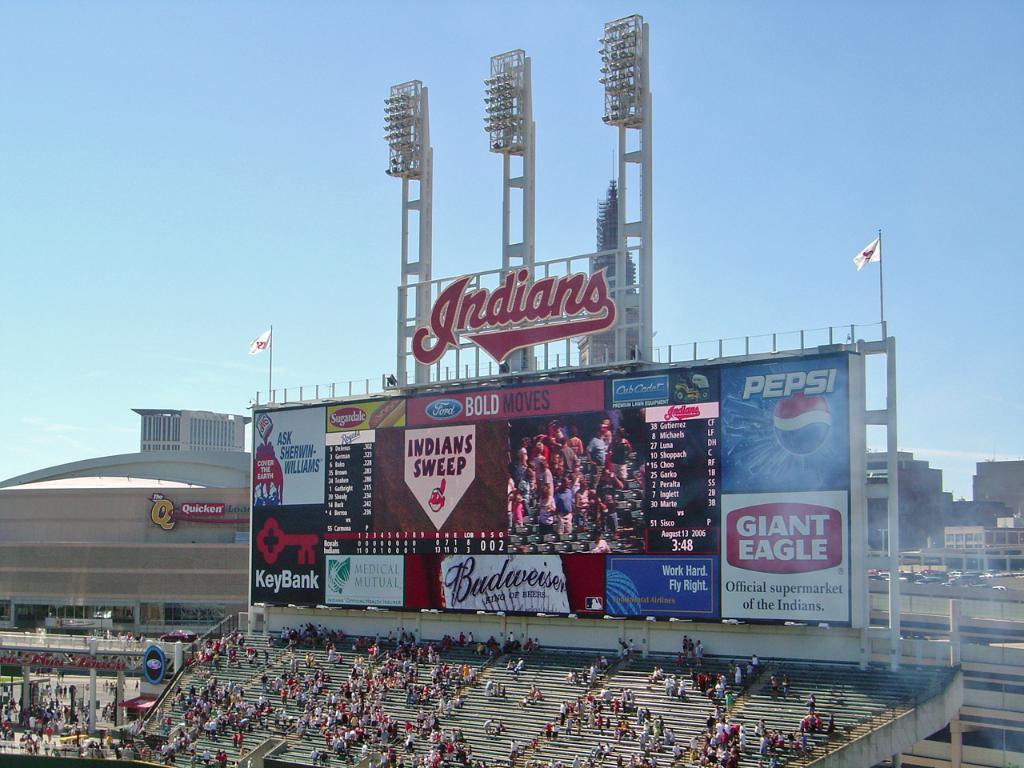<image>
Offer a succinct explanation of the picture presented. A view of an Indian stadium showing placards by Pepsi, Giant Eagle etc. and a scoreboard 